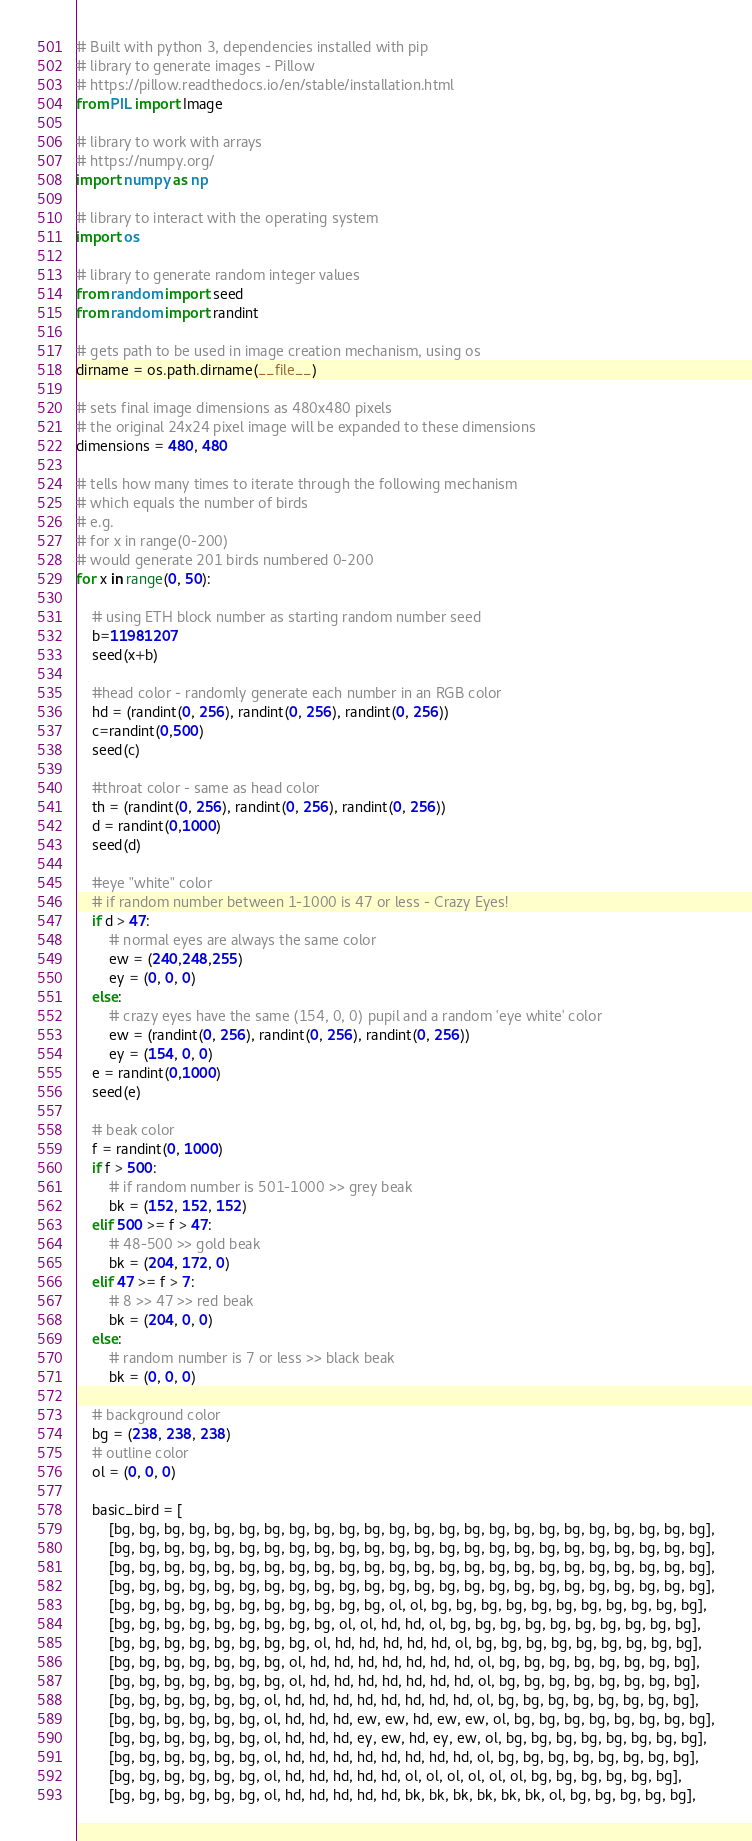Convert code to text. <code><loc_0><loc_0><loc_500><loc_500><_Python_># Built with python 3, dependencies installed with pip 
# library to generate images - Pillow 
# https://pillow.readthedocs.io/en/stable/installation.html
from PIL import Image

# library to work with arrays 
# https://numpy.org/
import numpy as np

# library to interact with the operating system
import os

# library to generate random integer values
from random import seed
from random import randint

# gets path to be used in image creation mechanism, using os
dirname = os.path.dirname(__file__)

# sets final image dimensions as 480x480 pixels
# the original 24x24 pixel image will be expanded to these dimensions
dimensions = 480, 480

# tells how many times to iterate through the following mechanism
# which equals the number of birds
# e.g. 
# for x in range(0-200) 
# would generate 201 birds numbered 0-200
for x in range(0, 50):

    # using ETH block number as starting random number seed
    b=11981207
    seed(x+b)

    #head color - randomly generate each number in an RGB color
    hd = (randint(0, 256), randint(0, 256), randint(0, 256))
    c=randint(0,500)
    seed(c)

    #throat color - same as head color
    th = (randint(0, 256), randint(0, 256), randint(0, 256))
    d = randint(0,1000)
    seed(d)

    #eye "white" color
    # if random number between 1-1000 is 47 or less - Crazy Eyes!
    if d > 47:
        # normal eyes are always the same color
        ew = (240,248,255)
        ey = (0, 0, 0)
    else:
        # crazy eyes have the same (154, 0, 0) pupil and a random 'eye white' color
        ew = (randint(0, 256), randint(0, 256), randint(0, 256))
        ey = (154, 0, 0)
    e = randint(0,1000)
    seed(e)

    # beak color
    f = randint(0, 1000)
    if f > 500:
        # if random number is 501-1000 >> grey beak
        bk = (152, 152, 152)
    elif 500 >= f > 47:
        # 48-500 >> gold beak
        bk = (204, 172, 0)
    elif 47 >= f > 7:
        # 8 >> 47 >> red beak
        bk = (204, 0, 0) 
    else:
        # random number is 7 or less >> black beak
        bk = (0, 0, 0) 

    # background color
    bg = (238, 238, 238)
    # outline color
    ol = (0, 0, 0)

    basic_bird = [
        [bg, bg, bg, bg, bg, bg, bg, bg, bg, bg, bg, bg, bg, bg, bg, bg, bg, bg, bg, bg, bg, bg, bg, bg],
        [bg, bg, bg, bg, bg, bg, bg, bg, bg, bg, bg, bg, bg, bg, bg, bg, bg, bg, bg, bg, bg, bg, bg, bg],
        [bg, bg, bg, bg, bg, bg, bg, bg, bg, bg, bg, bg, bg, bg, bg, bg, bg, bg, bg, bg, bg, bg, bg, bg],
        [bg, bg, bg, bg, bg, bg, bg, bg, bg, bg, bg, bg, bg, bg, bg, bg, bg, bg, bg, bg, bg, bg, bg, bg],
        [bg, bg, bg, bg, bg, bg, bg, bg, bg, bg, bg, ol, ol, bg, bg, bg, bg, bg, bg, bg, bg, bg, bg, bg],
        [bg, bg, bg, bg, bg, bg, bg, bg, bg, ol, ol, hd, hd, ol, bg, bg, bg, bg, bg, bg, bg, bg, bg, bg],
        [bg, bg, bg, bg, bg, bg, bg, bg, ol, hd, hd, hd, hd, hd, ol, bg, bg, bg, bg, bg, bg, bg, bg, bg],
        [bg, bg, bg, bg, bg, bg, bg, ol, hd, hd, hd, hd, hd, hd, hd, ol, bg, bg, bg, bg, bg, bg, bg, bg],
        [bg, bg, bg, bg, bg, bg, bg, ol, hd, hd, hd, hd, hd, hd, hd, ol, bg, bg, bg, bg, bg, bg, bg, bg],
        [bg, bg, bg, bg, bg, bg, ol, hd, hd, hd, hd, hd, hd, hd, hd, ol, bg, bg, bg, bg, bg, bg, bg, bg],
        [bg, bg, bg, bg, bg, bg, ol, hd, hd, hd, ew, ew, hd, ew, ew, ol, bg, bg, bg, bg, bg, bg, bg, bg],
        [bg, bg, bg, bg, bg, bg, ol, hd, hd, hd, ey, ew, hd, ey, ew, ol, bg, bg, bg, bg, bg, bg, bg, bg],
        [bg, bg, bg, bg, bg, bg, ol, hd, hd, hd, hd, hd, hd, hd, hd, ol, bg, bg, bg, bg, bg, bg, bg, bg],
        [bg, bg, bg, bg, bg, bg, ol, hd, hd, hd, hd, hd, ol, ol, ol, ol, ol, ol, bg, bg, bg, bg, bg, bg],
        [bg, bg, bg, bg, bg, bg, ol, hd, hd, hd, hd, hd, bk, bk, bk, bk, bk, bk, ol, bg, bg, bg, bg, bg],</code> 